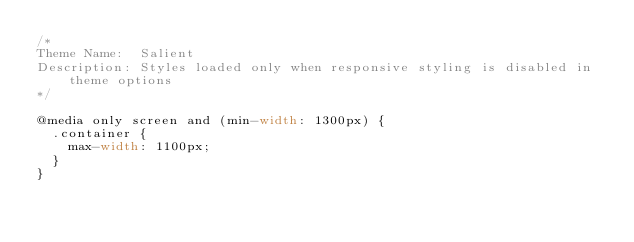<code> <loc_0><loc_0><loc_500><loc_500><_CSS_>/*
Theme Name:  Salient
Description: Styles loaded only when responsive styling is disabled in theme options
*/

@media only screen and (min-width: 1300px) {
  .container {
    max-width: 1100px;  
  } 
}

</code> 